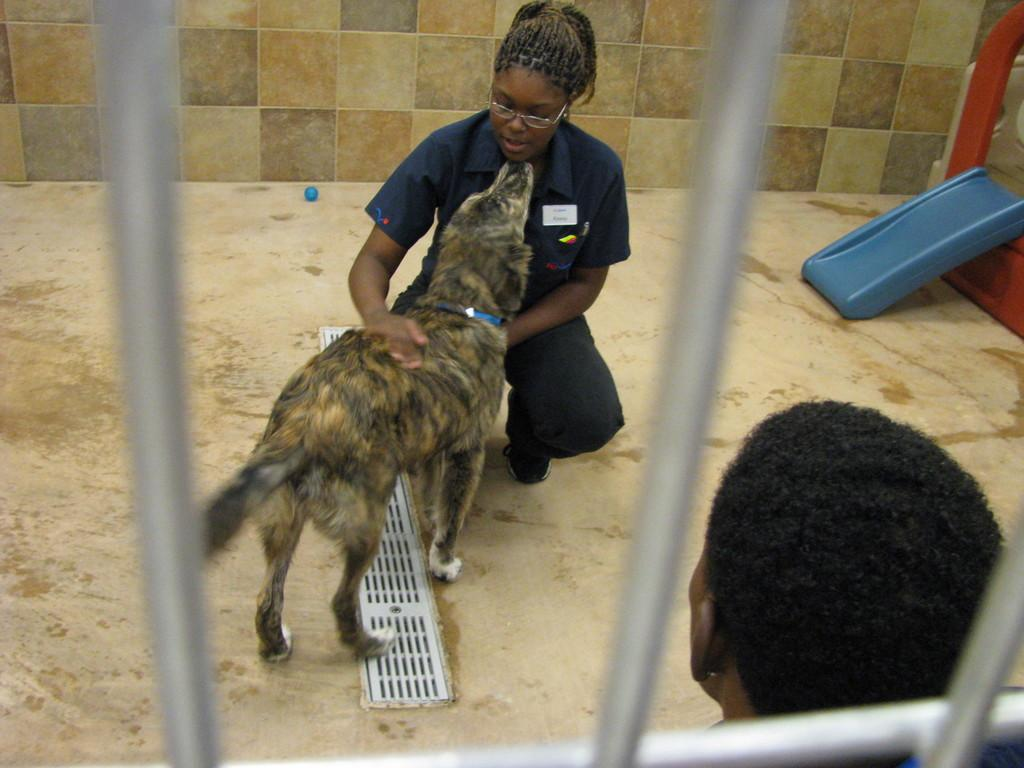What type of flooring is visible in the image? There are tiles in the image. What animal can be seen in the image? There is a dog in the image. How many people are sitting in the image? There are two people sitting in the image. What type of engine is powering the dog in the image? There is no engine present in the image, and the dog is not being powered by any engine. How does the sun appear in the image? The sun is not visible in the image; it is an indoor scene. 